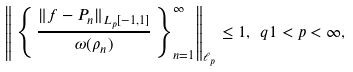<formula> <loc_0><loc_0><loc_500><loc_500>\left \| \, \left \{ \, \frac { \| f - P _ { n } \| _ { L _ { p } [ - 1 , 1 ] } } { \omega ( \rho _ { n } ) } \, \right \} ^ { \infty } _ { n = 1 } \right \| _ { \ell _ { p } } \leq 1 , \ q 1 < p < \infty ,</formula> 